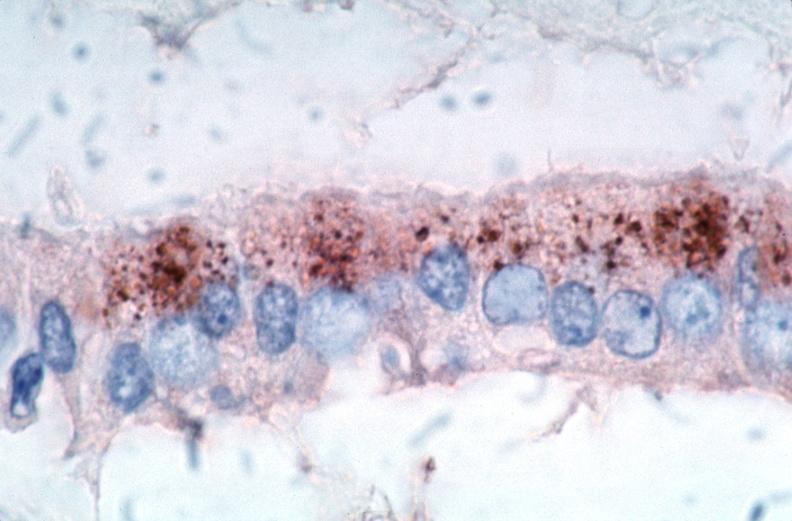what is present?
Answer the question using a single word or phrase. Vasculature 